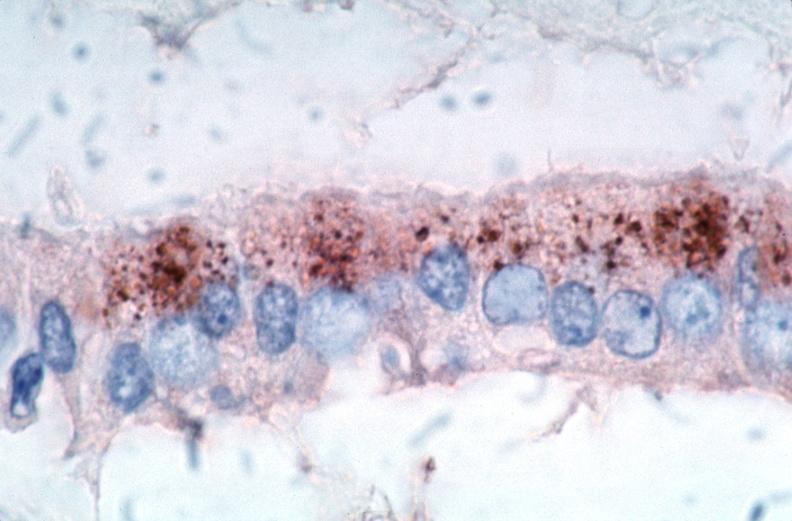what is present?
Answer the question using a single word or phrase. Vasculature 